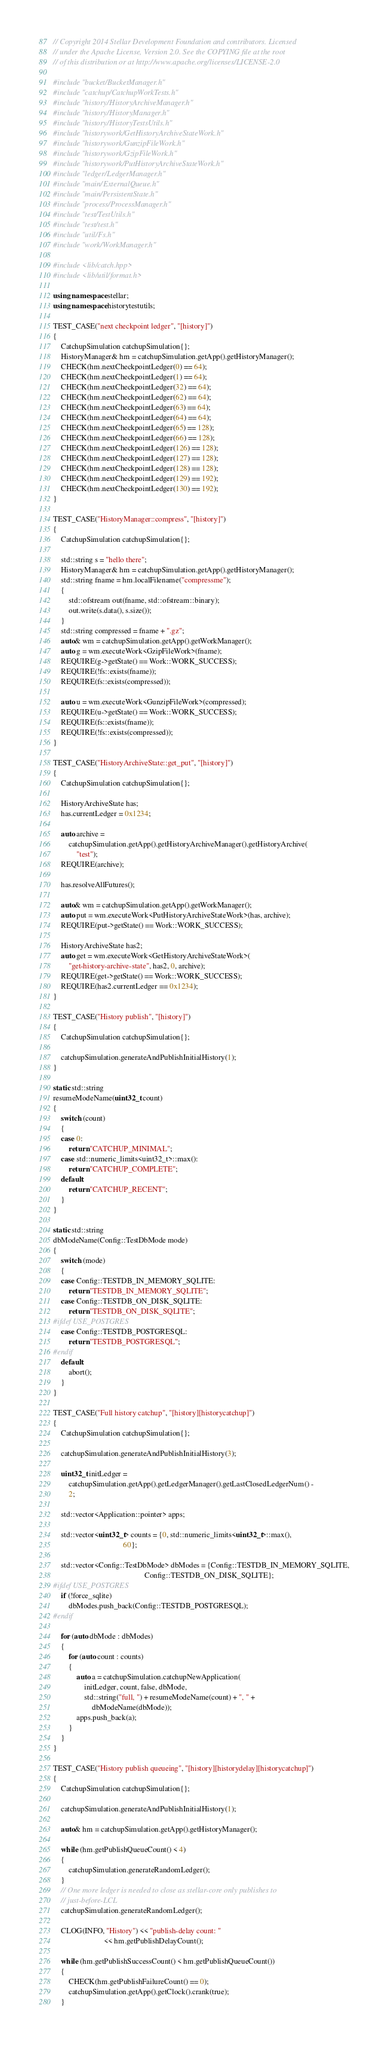<code> <loc_0><loc_0><loc_500><loc_500><_C++_>// Copyright 2014 Stellar Development Foundation and contributors. Licensed
// under the Apache License, Version 2.0. See the COPYING file at the root
// of this distribution or at http://www.apache.org/licenses/LICENSE-2.0

#include "bucket/BucketManager.h"
#include "catchup/CatchupWorkTests.h"
#include "history/HistoryArchiveManager.h"
#include "history/HistoryManager.h"
#include "history/HistoryTestsUtils.h"
#include "historywork/GetHistoryArchiveStateWork.h"
#include "historywork/GunzipFileWork.h"
#include "historywork/GzipFileWork.h"
#include "historywork/PutHistoryArchiveStateWork.h"
#include "ledger/LedgerManager.h"
#include "main/ExternalQueue.h"
#include "main/PersistentState.h"
#include "process/ProcessManager.h"
#include "test/TestUtils.h"
#include "test/test.h"
#include "util/Fs.h"
#include "work/WorkManager.h"

#include <lib/catch.hpp>
#include <lib/util/format.h>

using namespace stellar;
using namespace historytestutils;

TEST_CASE("next checkpoint ledger", "[history]")
{
    CatchupSimulation catchupSimulation{};
    HistoryManager& hm = catchupSimulation.getApp().getHistoryManager();
    CHECK(hm.nextCheckpointLedger(0) == 64);
    CHECK(hm.nextCheckpointLedger(1) == 64);
    CHECK(hm.nextCheckpointLedger(32) == 64);
    CHECK(hm.nextCheckpointLedger(62) == 64);
    CHECK(hm.nextCheckpointLedger(63) == 64);
    CHECK(hm.nextCheckpointLedger(64) == 64);
    CHECK(hm.nextCheckpointLedger(65) == 128);
    CHECK(hm.nextCheckpointLedger(66) == 128);
    CHECK(hm.nextCheckpointLedger(126) == 128);
    CHECK(hm.nextCheckpointLedger(127) == 128);
    CHECK(hm.nextCheckpointLedger(128) == 128);
    CHECK(hm.nextCheckpointLedger(129) == 192);
    CHECK(hm.nextCheckpointLedger(130) == 192);
}

TEST_CASE("HistoryManager::compress", "[history]")
{
    CatchupSimulation catchupSimulation{};

    std::string s = "hello there";
    HistoryManager& hm = catchupSimulation.getApp().getHistoryManager();
    std::string fname = hm.localFilename("compressme");
    {
        std::ofstream out(fname, std::ofstream::binary);
        out.write(s.data(), s.size());
    }
    std::string compressed = fname + ".gz";
    auto& wm = catchupSimulation.getApp().getWorkManager();
    auto g = wm.executeWork<GzipFileWork>(fname);
    REQUIRE(g->getState() == Work::WORK_SUCCESS);
    REQUIRE(!fs::exists(fname));
    REQUIRE(fs::exists(compressed));

    auto u = wm.executeWork<GunzipFileWork>(compressed);
    REQUIRE(u->getState() == Work::WORK_SUCCESS);
    REQUIRE(fs::exists(fname));
    REQUIRE(!fs::exists(compressed));
}

TEST_CASE("HistoryArchiveState::get_put", "[history]")
{
    CatchupSimulation catchupSimulation{};

    HistoryArchiveState has;
    has.currentLedger = 0x1234;

    auto archive =
        catchupSimulation.getApp().getHistoryArchiveManager().getHistoryArchive(
            "test");
    REQUIRE(archive);

    has.resolveAllFutures();

    auto& wm = catchupSimulation.getApp().getWorkManager();
    auto put = wm.executeWork<PutHistoryArchiveStateWork>(has, archive);
    REQUIRE(put->getState() == Work::WORK_SUCCESS);

    HistoryArchiveState has2;
    auto get = wm.executeWork<GetHistoryArchiveStateWork>(
        "get-history-archive-state", has2, 0, archive);
    REQUIRE(get->getState() == Work::WORK_SUCCESS);
    REQUIRE(has2.currentLedger == 0x1234);
}

TEST_CASE("History publish", "[history]")
{
    CatchupSimulation catchupSimulation{};

    catchupSimulation.generateAndPublishInitialHistory(1);
}

static std::string
resumeModeName(uint32_t count)
{
    switch (count)
    {
    case 0:
        return "CATCHUP_MINIMAL";
    case std::numeric_limits<uint32_t>::max():
        return "CATCHUP_COMPLETE";
    default:
        return "CATCHUP_RECENT";
    }
}

static std::string
dbModeName(Config::TestDbMode mode)
{
    switch (mode)
    {
    case Config::TESTDB_IN_MEMORY_SQLITE:
        return "TESTDB_IN_MEMORY_SQLITE";
    case Config::TESTDB_ON_DISK_SQLITE:
        return "TESTDB_ON_DISK_SQLITE";
#ifdef USE_POSTGRES
    case Config::TESTDB_POSTGRESQL:
        return "TESTDB_POSTGRESQL";
#endif
    default:
        abort();
    }
}

TEST_CASE("Full history catchup", "[history][historycatchup]")
{
    CatchupSimulation catchupSimulation{};

    catchupSimulation.generateAndPublishInitialHistory(3);

    uint32_t initLedger =
        catchupSimulation.getApp().getLedgerManager().getLastClosedLedgerNum() -
        2;

    std::vector<Application::pointer> apps;

    std::vector<uint32_t> counts = {0, std::numeric_limits<uint32_t>::max(),
                                    60};

    std::vector<Config::TestDbMode> dbModes = {Config::TESTDB_IN_MEMORY_SQLITE,
                                               Config::TESTDB_ON_DISK_SQLITE};
#ifdef USE_POSTGRES
    if (!force_sqlite)
        dbModes.push_back(Config::TESTDB_POSTGRESQL);
#endif

    for (auto dbMode : dbModes)
    {
        for (auto count : counts)
        {
            auto a = catchupSimulation.catchupNewApplication(
                initLedger, count, false, dbMode,
                std::string("full, ") + resumeModeName(count) + ", " +
                    dbModeName(dbMode));
            apps.push_back(a);
        }
    }
}

TEST_CASE("History publish queueing", "[history][historydelay][historycatchup]")
{
    CatchupSimulation catchupSimulation{};

    catchupSimulation.generateAndPublishInitialHistory(1);

    auto& hm = catchupSimulation.getApp().getHistoryManager();

    while (hm.getPublishQueueCount() < 4)
    {
        catchupSimulation.generateRandomLedger();
    }
    // One more ledger is needed to close as stellar-core only publishes to
    // just-before-LCL
    catchupSimulation.generateRandomLedger();

    CLOG(INFO, "History") << "publish-delay count: "
                          << hm.getPublishDelayCount();

    while (hm.getPublishSuccessCount() < hm.getPublishQueueCount())
    {
        CHECK(hm.getPublishFailureCount() == 0);
        catchupSimulation.getApp().getClock().crank(true);
    }
</code> 